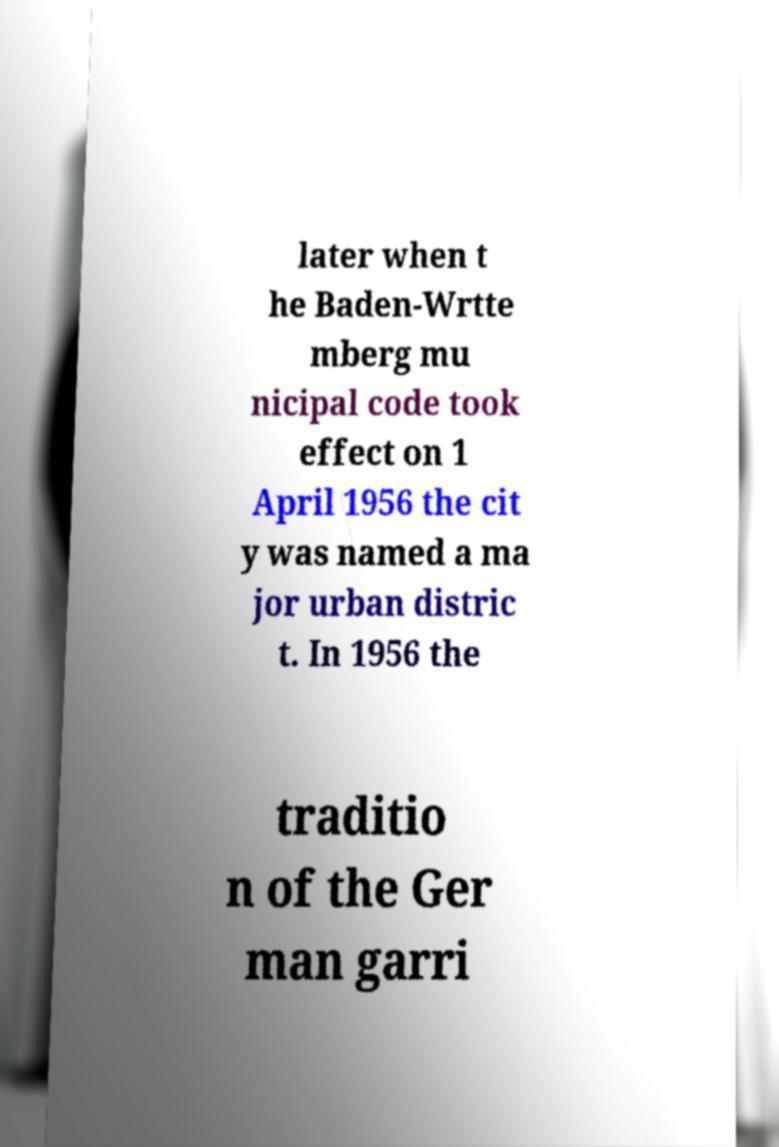For documentation purposes, I need the text within this image transcribed. Could you provide that? later when t he Baden-Wrtte mberg mu nicipal code took effect on 1 April 1956 the cit y was named a ma jor urban distric t. In 1956 the traditio n of the Ger man garri 